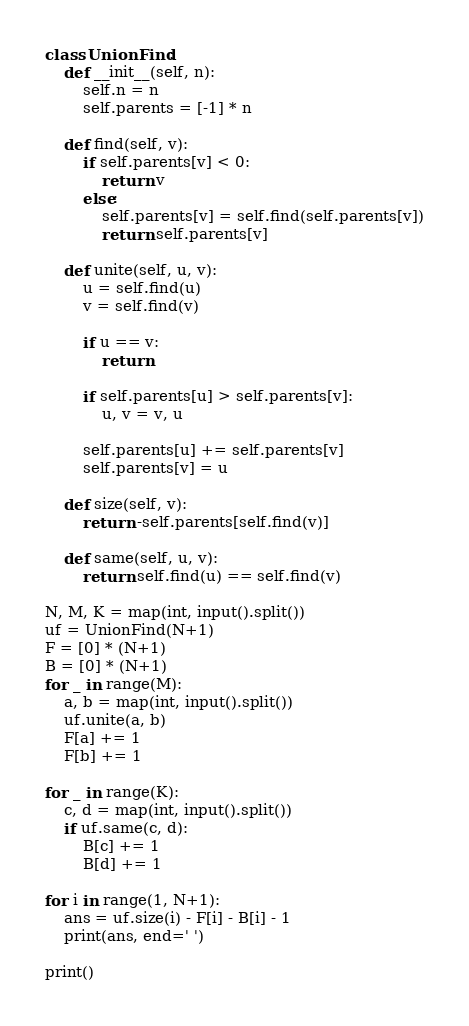<code> <loc_0><loc_0><loc_500><loc_500><_Python_>class UnionFind:
    def __init__(self, n):
        self.n = n
        self.parents = [-1] * n

    def find(self, v):
        if self.parents[v] < 0:
            return v
        else:
            self.parents[v] = self.find(self.parents[v])
            return self.parents[v]

    def unite(self, u, v):
        u = self.find(u)
        v = self.find(v)

        if u == v:
            return

        if self.parents[u] > self.parents[v]:
            u, v = v, u

        self.parents[u] += self.parents[v]
        self.parents[v] = u

    def size(self, v):
        return -self.parents[self.find(v)]

    def same(self, u, v):
        return self.find(u) == self.find(v)

N, M, K = map(int, input().split())
uf = UnionFind(N+1)
F = [0] * (N+1)
B = [0] * (N+1)
for _ in range(M):
    a, b = map(int, input().split())
    uf.unite(a, b)
    F[a] += 1
    F[b] += 1

for _ in range(K):
    c, d = map(int, input().split())
    if uf.same(c, d):
        B[c] += 1
        B[d] += 1

for i in range(1, N+1):
    ans = uf.size(i) - F[i] - B[i] - 1
    print(ans, end=' ')

print()</code> 